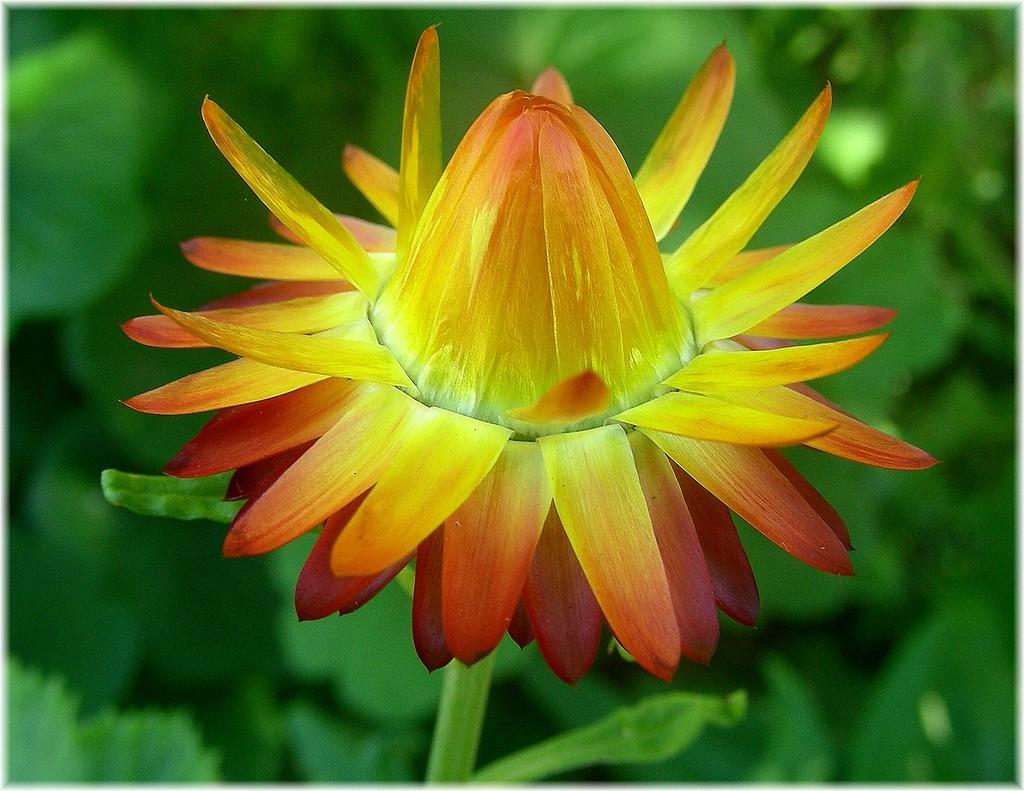What is the main subject of the painting in the image? The main subject of the painting in the image is flowers. What can be seen in the background of the painting? There are plants and leaves visible in the background of the image. What type of glue is used to attach the fang to the painting in the image? There is no glue or fang present in the image; it is a painting of flowers with plants and leaves in the background. 